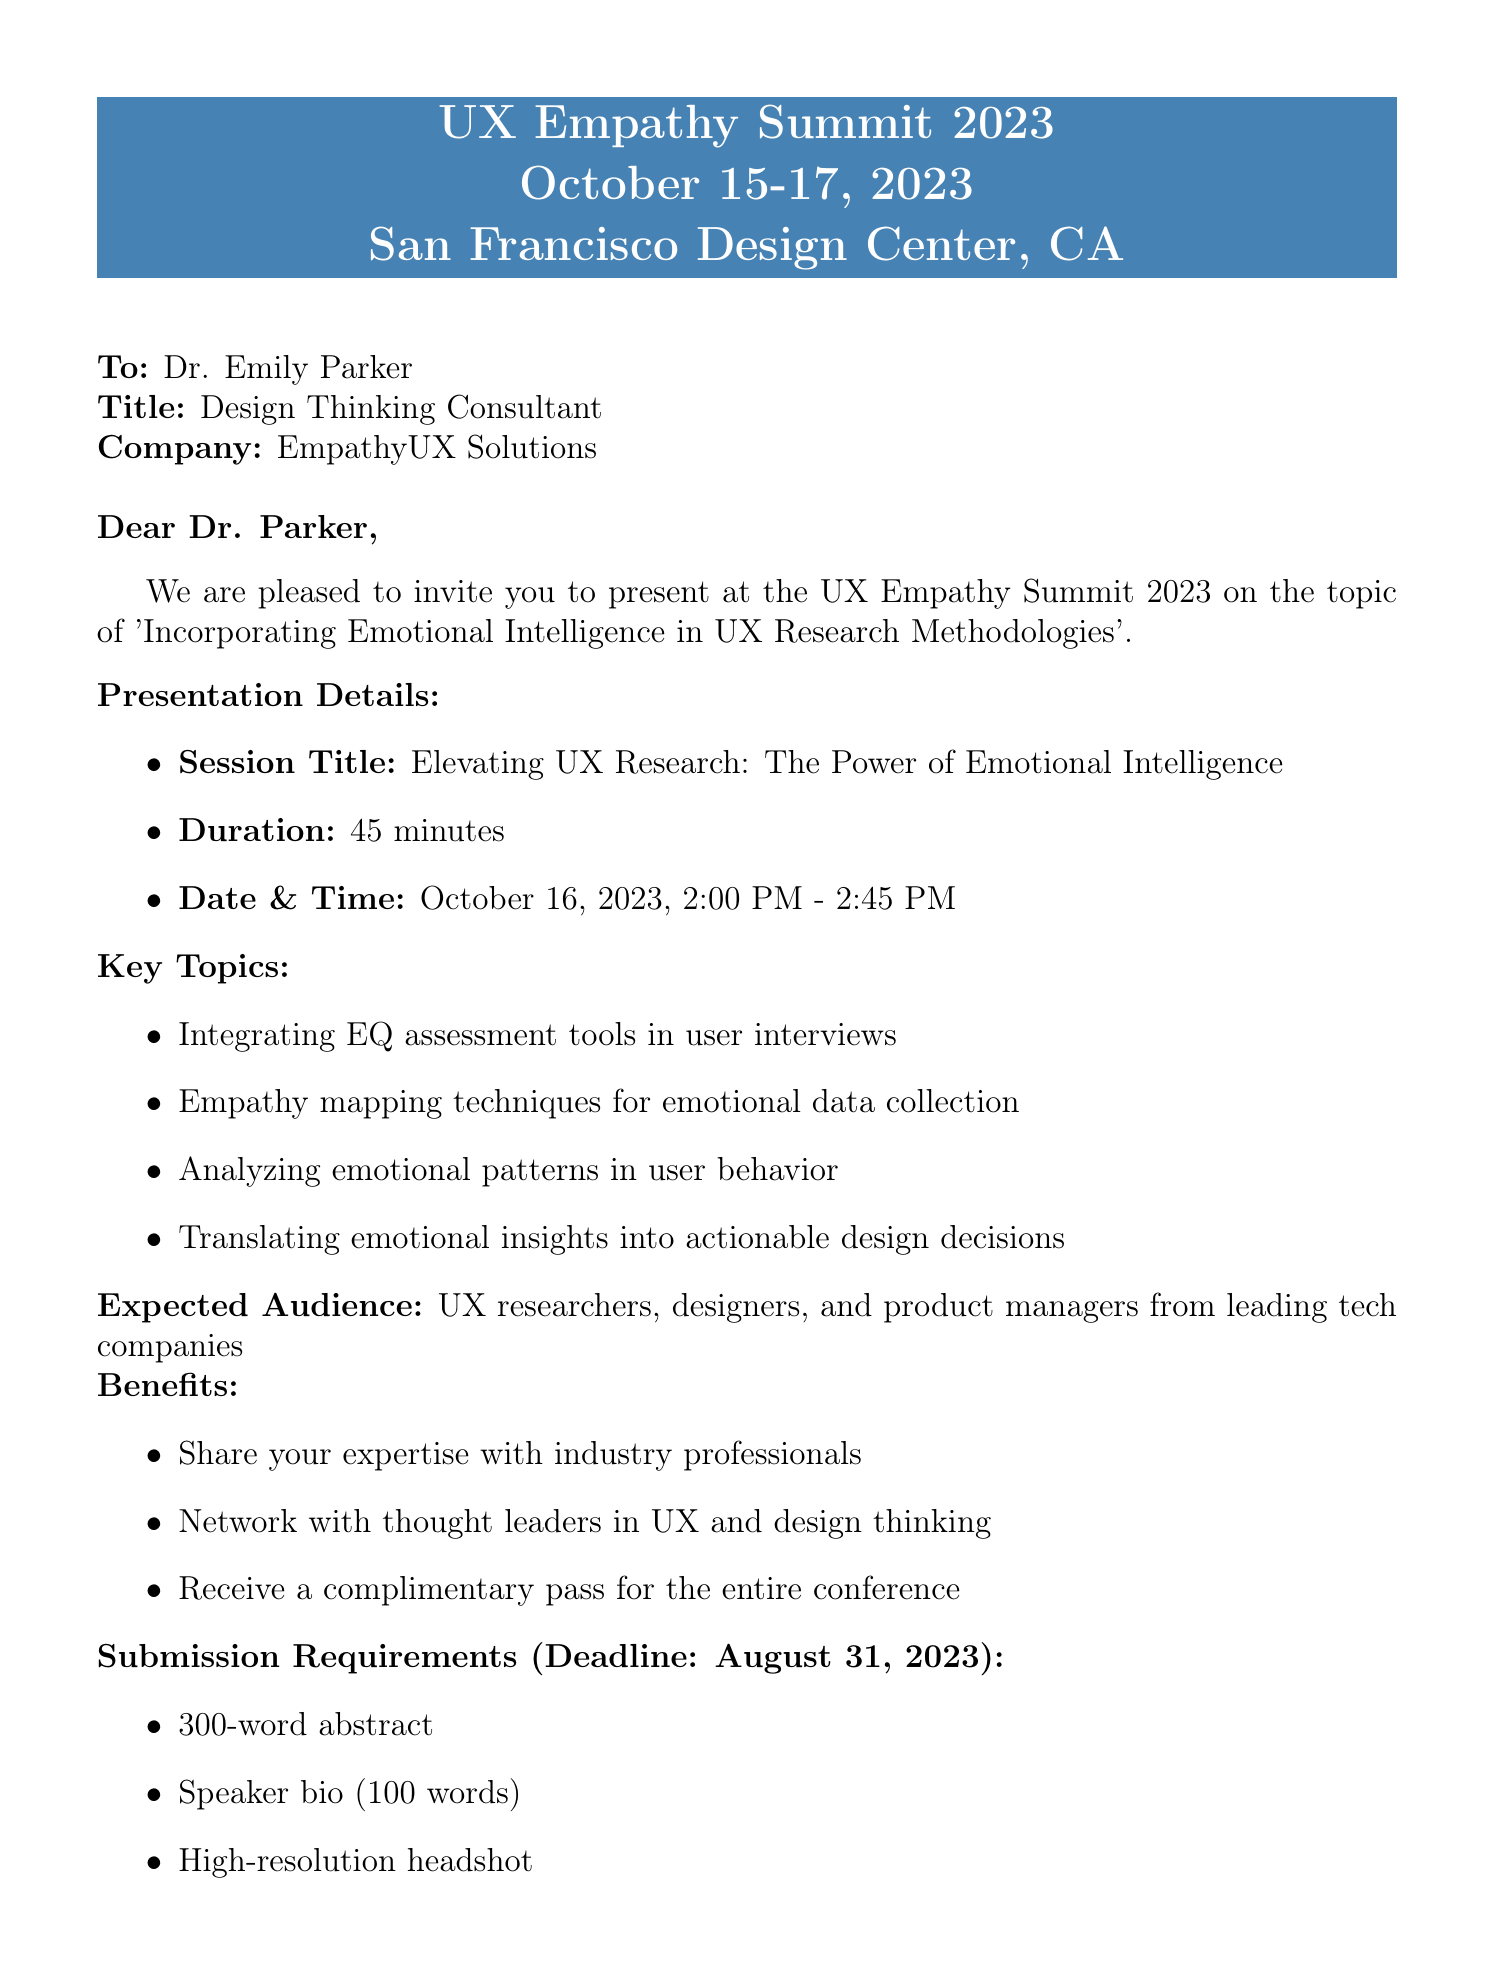What is the title of the conference? The title of the conference is stated at the beginning of the document.
Answer: UX Empathy Summit 2023 When is the conference taking place? The document specifies the dates of the conference.
Answer: October 15-17, 2023 Who is invited to present? The document addresses the invitee directly.
Answer: Dr. Emily Parker What is the duration of the presentation? The document explicitly states the duration of the session.
Answer: 45 minutes What is the expected audience for the presentation? The document describes the expected attendees of the session.
Answer: UX researchers, designers, and product managers What is the submission deadline for the requirements? The deadline for submission is mentioned directly in the document.
Answer: August 31, 2023 What type of insights will be analyzed according to the key topics? The document outlines specific insights to be discussed in the presentation.
Answer: Emotional patterns in user behavior Who should be contacted for questions regarding the conference? The document provides a contact person for inquiries.
Answer: Sarah Thompson What will the speaker receive for participating in the conference? The document lists the benefits for the speaker.
Answer: A complimentary pass for the entire conference What is the session title for Dr. Parker's presentation? The document specifies the title of Dr. Parker's session.
Answer: Elevating UX Research: The Power of Emotional Intelligence 